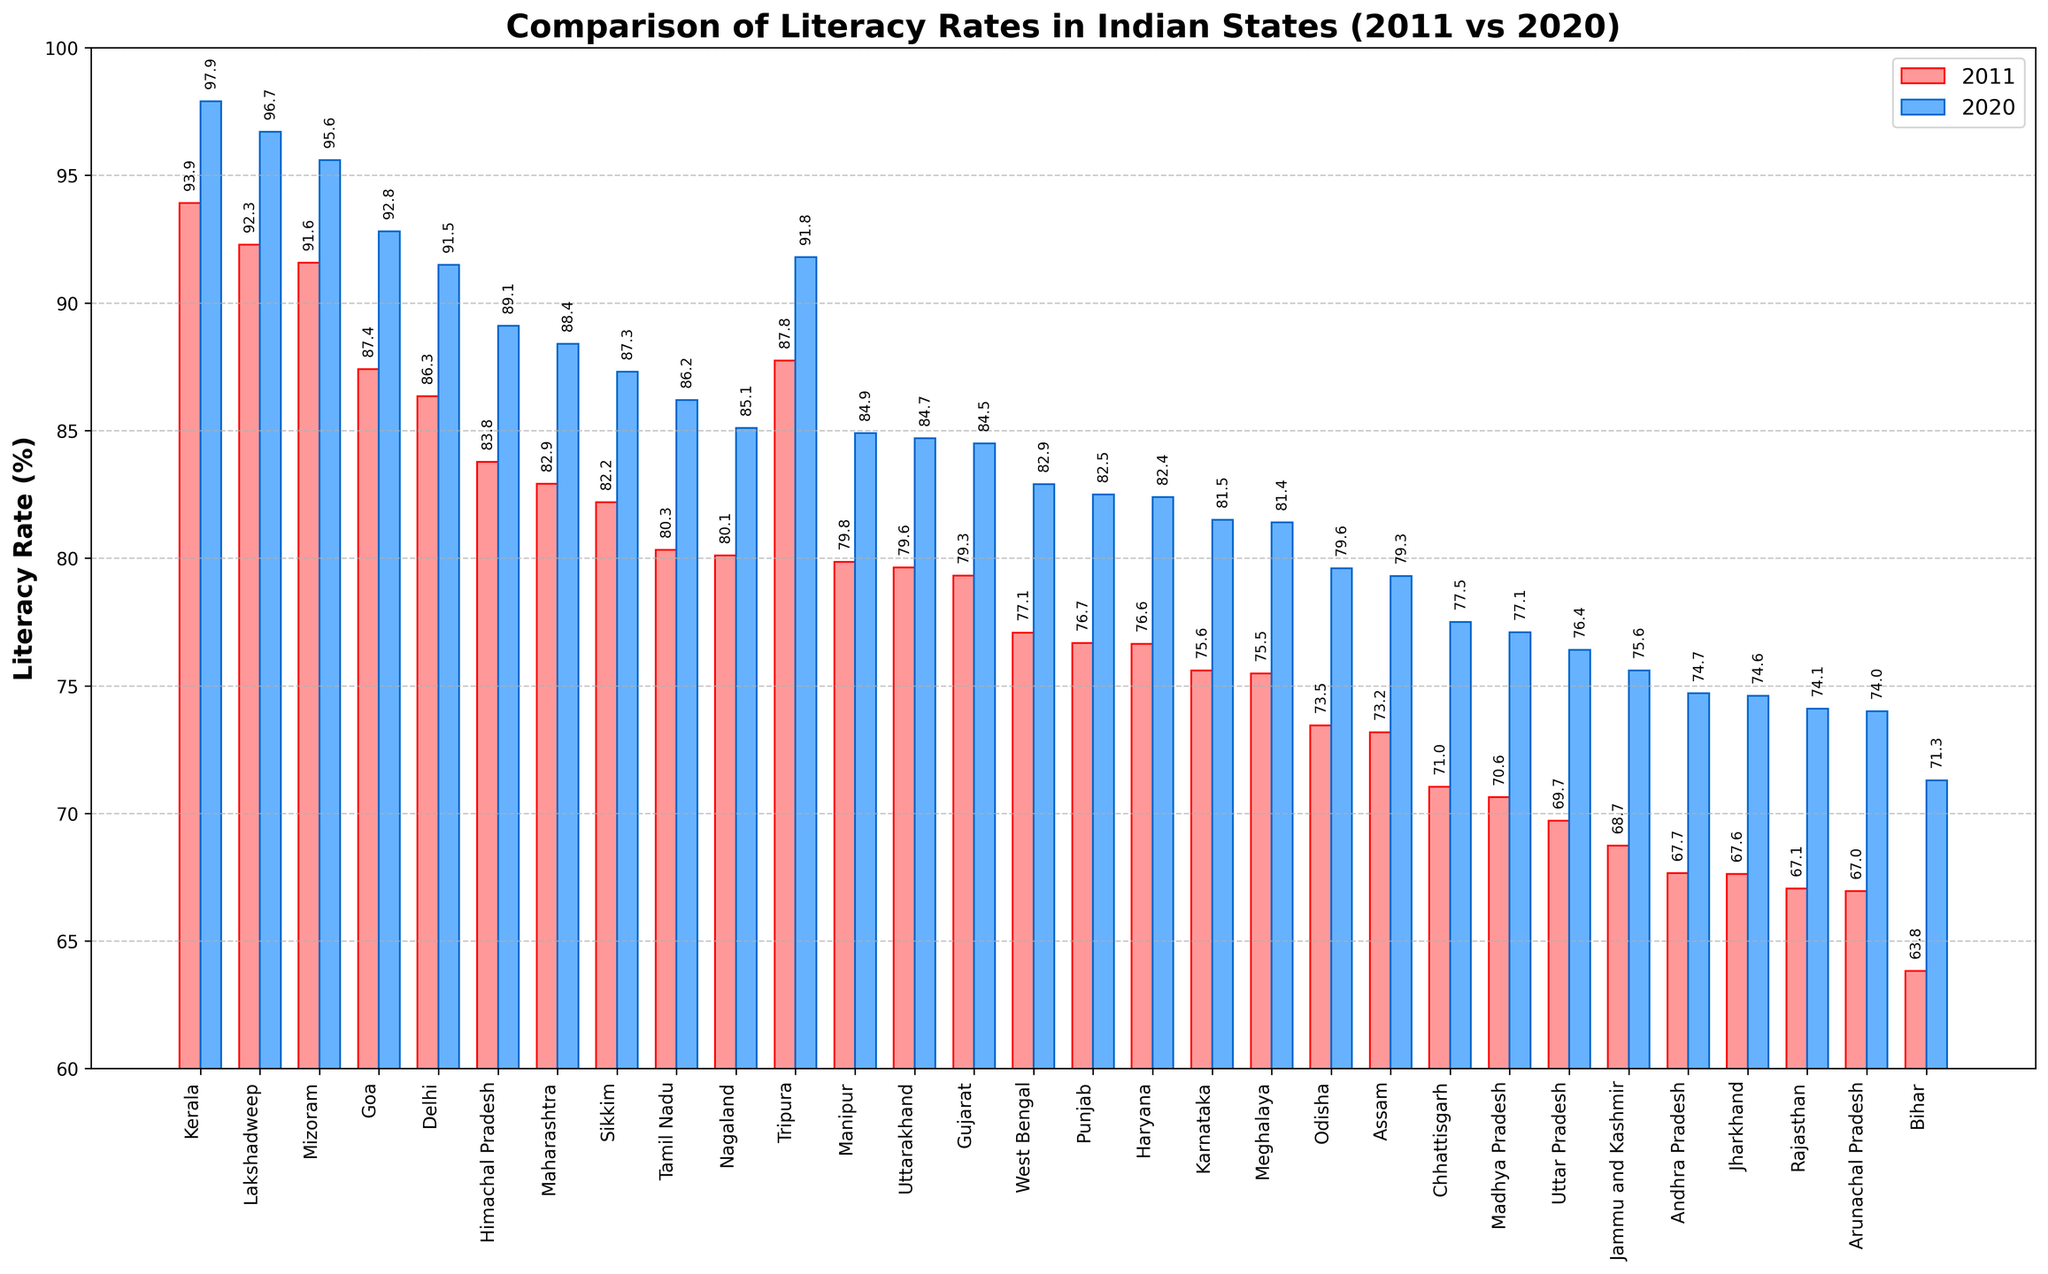Which state had the highest literacy rate in 2020? To find the state with the highest literacy rate in 2020, look at the blue bars and identify the highest one. Kerala has the highest blue bar at 97.9%.
Answer: Kerala What is the difference in literacy rates between Kerala and Bihar in 2011? To find the difference, subtract Bihar's 2011 literacy rate from Kerala's 2011 literacy rate. Kerala had 93.91% and Bihar had 63.82%. So, 93.91 - 63.82 = 30.09%.
Answer: 30.09% How much did the literacy rate in Andhra Pradesh increase from 2011 to 2020? Calculate the difference in literacy rates for Andhra Pradesh from 2011 to 2020: 74.7% - 67.66% = 7.04%.
Answer: 7.04% Which states had a literacy rate above 90% in 2020? Identify all the blue bars that reach above the 90% mark. The states that meet this criterion are Kerala, Lakshadweep, Mizoram, Goa, Delhi, and Tripura.
Answer: Kerala, Lakshadweep, Mizoram, Goa, Delhi, Tripura Which state showed the smallest increase in literacy rate from 2011 to 2020? Compare the difference in literacy rates between 2011 and 2020 for each state. Goa's increase from 87.4% to 92.8% appears smaller compared to other states (5.4%).
Answer: Goa How does the increase in literacy rate for Mizoram compare to that of Nagaland from 2011 to 2020? Calculate the increase for both states. Mizoram: 95.6% - 91.58% = 4.02%, Nagaland: 85.1% - 80.11% = 5.0%. Mizoram (4.02%) showed a smaller increase than Nagaland (5.0%).
Answer: Mizoram's increase is smaller Which state had a lower literacy rate than the national average (assuming the average literacy rate is 77% in 2011) in 2011? Compare each state's 2011 literacy rate to 77%. Jammu and Kashmir (68.74%), Andhra Pradesh (67.66%), Jharkhand (67.63%), Rajasthan (67.06%), Arunachal Pradesh (66.95%), and Bihar (63.82%) had lower rates than the national average.
Answer: Jammu and Kashmir, Andhra Pradesh, Jharkhand, Rajasthan, Arunachal Pradesh, Bihar Which state is closest to achieving 100% literacy based on the 2020 data? Look for the state with the 2020 literacy rate closest to 100%. Kerala, with 97.9%, is closest to achieving 100% literacy.
Answer: Kerala What is the median literacy rate among all states in 2020? List all the 2020 literacy rates, sort them, and find the middle value. With 29 states, the middle value is the 15th entry when sorted: the sorted rates are: 71.3, 74, 74.1, 74.6, 74.7, 75.6, 76.4, 77.1, 77.5, 79.3, 79.6, 81.4, 81.5, 82.4, 82.5. The median is approximately 82.5%.
Answer: 82.5% Between 2011 and 2020, which state improved its literacy rate the most? Calculate the difference for each state between 2011 and 2020, then identify the largest increase. Bihar had an increase from 63.82% to 71.3%, a 7.48% increase, which is the highest among all states.
Answer: Bihar 